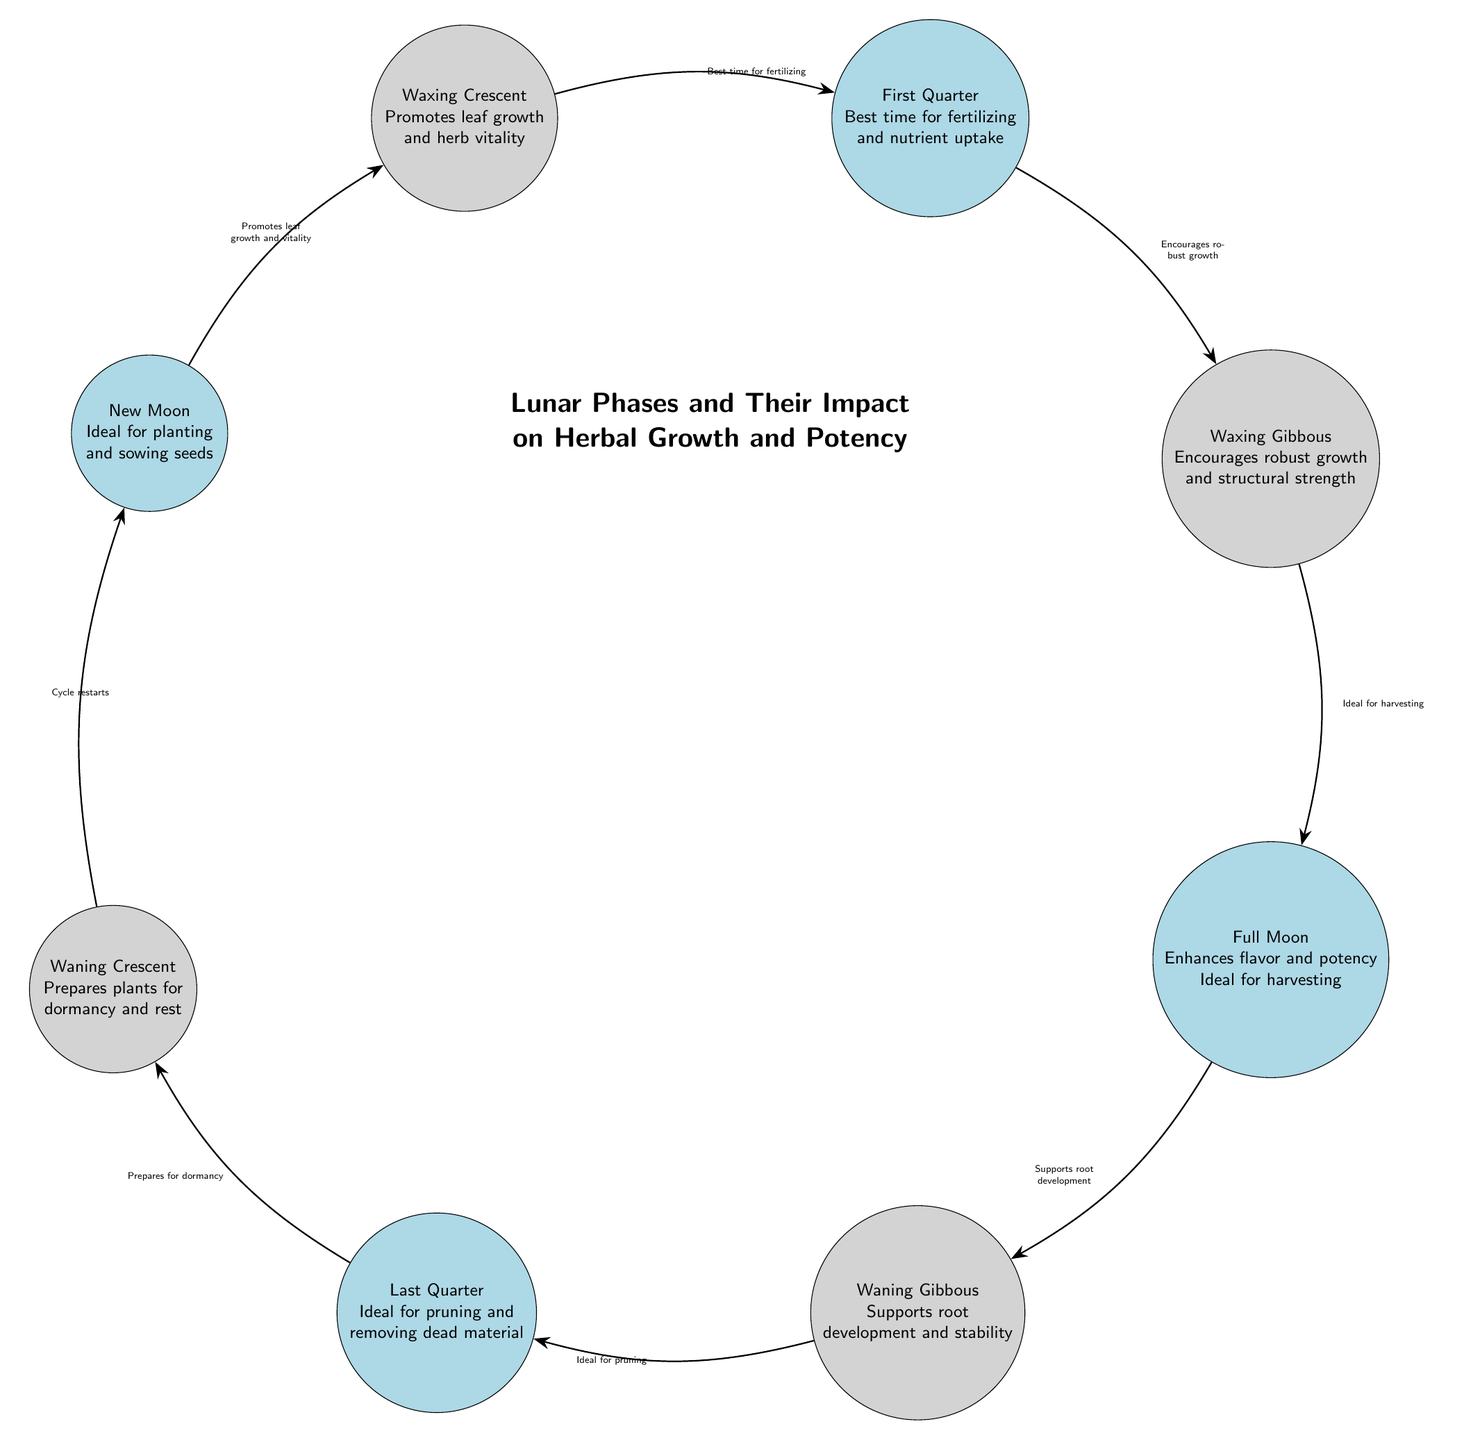What is the ideal phase for planting and sowing seeds? The diagram indicates that the New Moon phase is ideal for planting and sowing seeds, as represented in the corresponding node.
Answer: New Moon What phase promotes leaf growth and herb vitality? According to the diagram, the Waxing Crescent phase is the one that promotes leaf growth and herb vitality.
Answer: Waxing Crescent How many phases are represented in the diagram? By counting the nodes labeled with each lunar phase in the diagram, there are a total of eight phases represented.
Answer: 8 What phase is best for fertilizing? The diagram shows that the First Quarter phase is identified as the best time for fertilizing.
Answer: First Quarter Which phase enhances flavor and potency? Per the diagram, the Full Moon phase is marked as the time when flavor and potency are enhanced.
Answer: Full Moon What is the sequence from the New Moon to the Full Moon? Starting from the New Moon, the sequence flows to Waxing Crescent, then to First Quarter, followed by Waxing Gibbous, and finally reaching the Full Moon.
Answer: New Moon, Waxing Crescent, First Quarter, Waxing Gibbous, Full Moon What happens during the Last Quarter phase? The diagram states that the Last Quarter phase is ideal for pruning and removing dead material from plants.
Answer: Ideal for pruning Which phase prepares plants for dormancy and rest? According to the diagram, the Waning Crescent phase is responsible for preparing plants for dormancy and rest.
Answer: Waning Crescent What is the effect of the Full Moon on root development? The diagram indicates that the Full Moon does not directly support root development, as that is attributed to the Waning Gibbous phase instead.
Answer: Supports root development (Waning Gibbous) What is the primary action during the Waning Gibbous phase? The action highlighted in the diagram for the Waning Gibbous phase is supporting root development and stability, indicating its significance in plant growth.
Answer: Supports root development 